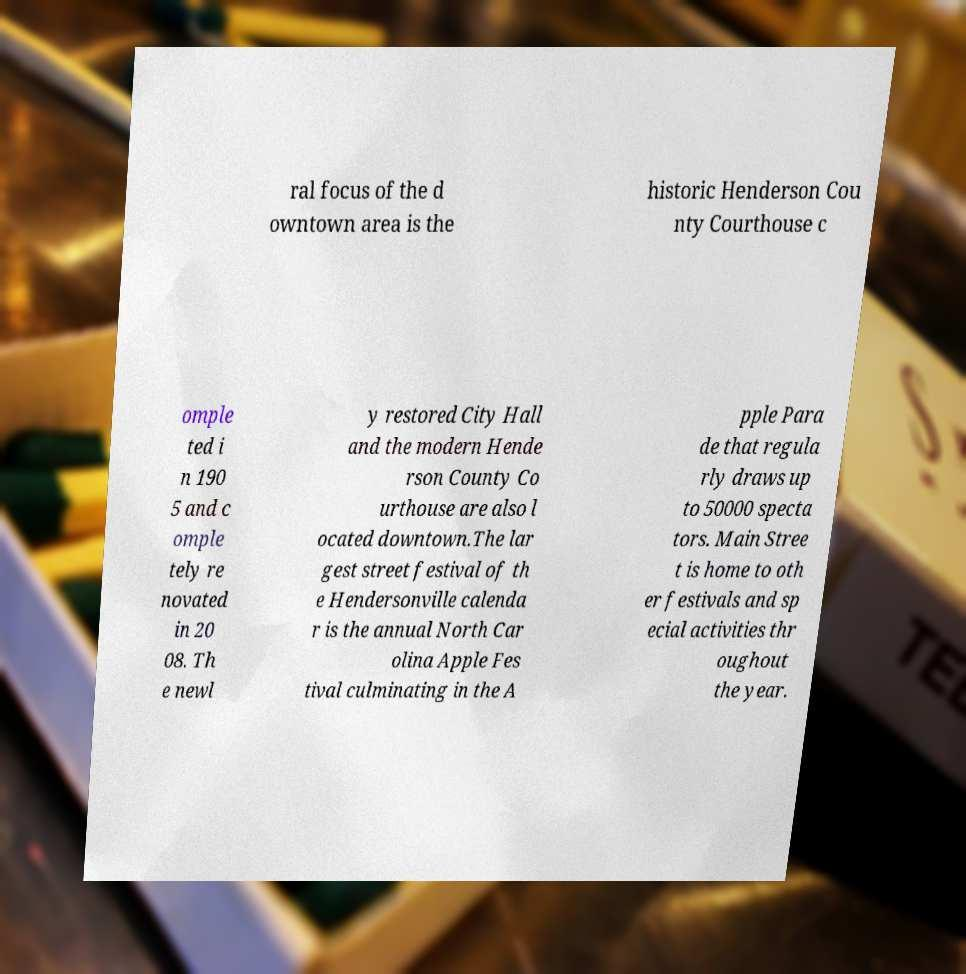Please read and relay the text visible in this image. What does it say? ral focus of the d owntown area is the historic Henderson Cou nty Courthouse c omple ted i n 190 5 and c omple tely re novated in 20 08. Th e newl y restored City Hall and the modern Hende rson County Co urthouse are also l ocated downtown.The lar gest street festival of th e Hendersonville calenda r is the annual North Car olina Apple Fes tival culminating in the A pple Para de that regula rly draws up to 50000 specta tors. Main Stree t is home to oth er festivals and sp ecial activities thr oughout the year. 